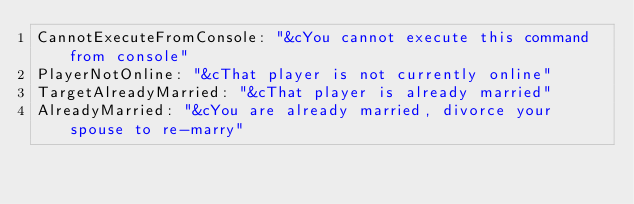Convert code to text. <code><loc_0><loc_0><loc_500><loc_500><_YAML_>CannotExecuteFromConsole: "&cYou cannot execute this command from console"
PlayerNotOnline: "&cThat player is not currently online"
TargetAlreadyMarried: "&cThat player is already married"
AlreadyMarried: "&cYou are already married, divorce your spouse to re-marry"</code> 